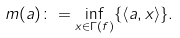Convert formula to latex. <formula><loc_0><loc_0><loc_500><loc_500>m ( a ) \colon = \inf _ { x \in \Gamma ( f ) } \{ \left \langle a , x \right \rangle \} .</formula> 